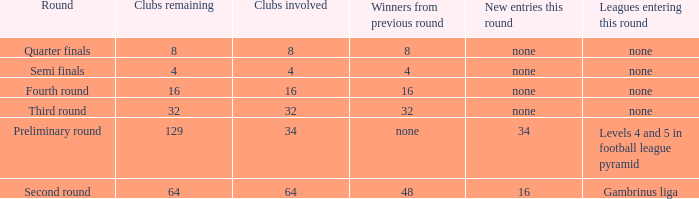Name the least clubs involved for leagues being none for semi finals 4.0. 